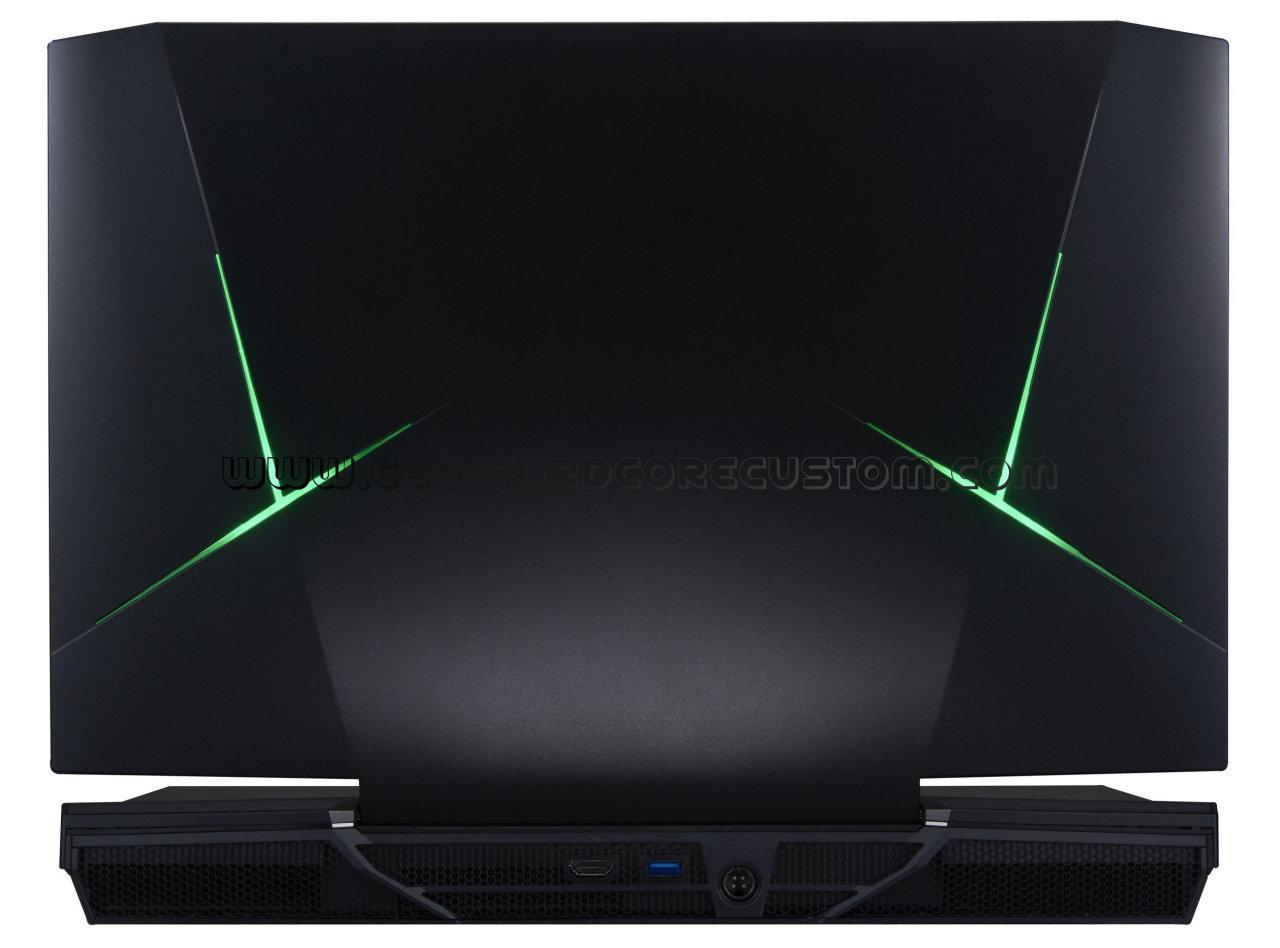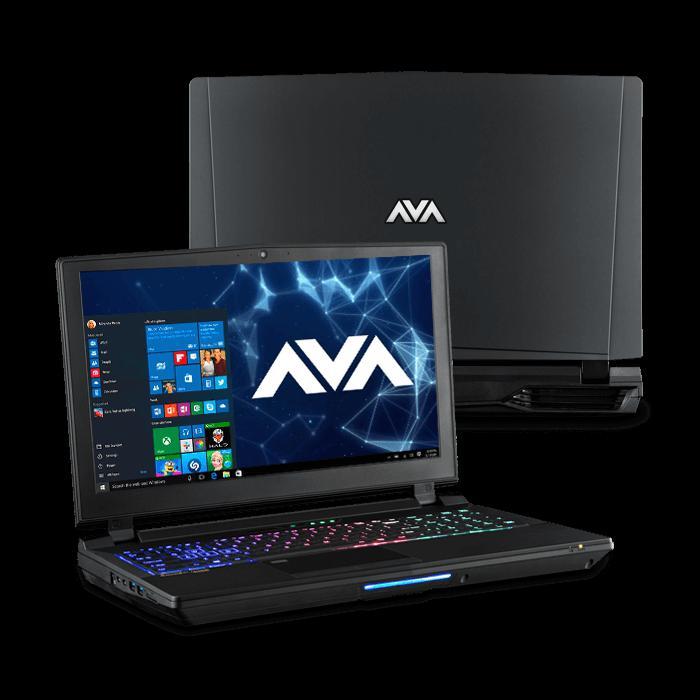The first image is the image on the left, the second image is the image on the right. Evaluate the accuracy of this statement regarding the images: "there is a laptop with rainbow colored lit up kets and a lit up light in front of the laptops base". Is it true? Answer yes or no. Yes. The first image is the image on the left, the second image is the image on the right. Analyze the images presented: Is the assertion "One image shows an open laptop viewed head-on and screen-first, and the other image shows an open laptop with a black screen displayed at an angle." valid? Answer yes or no. No. 